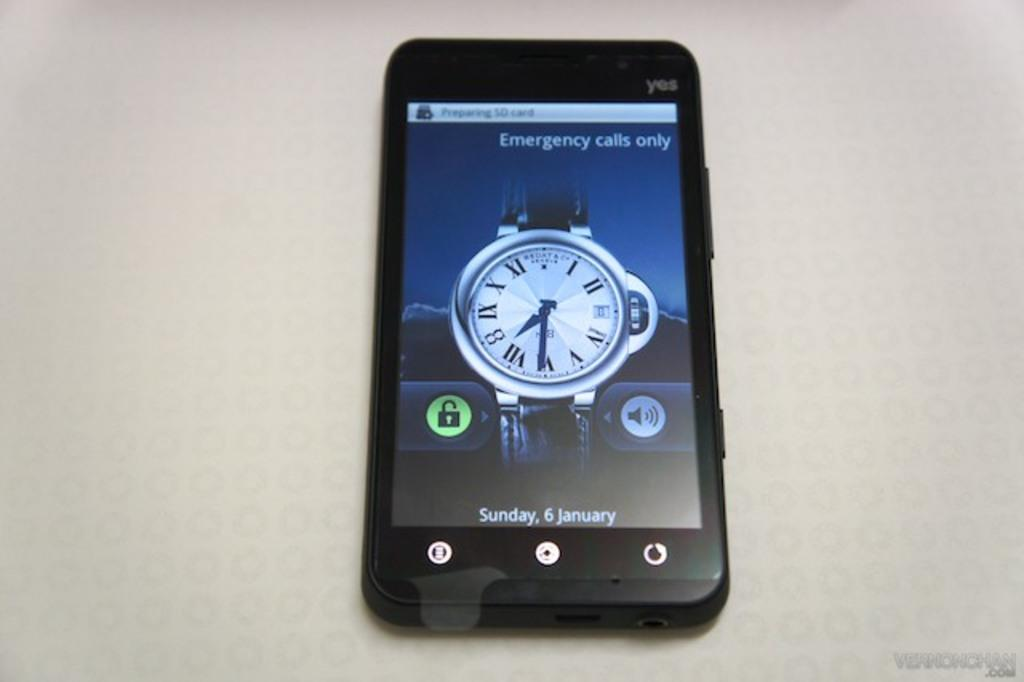<image>
Give a short and clear explanation of the subsequent image. The screen on the phone is set for emergency calls only. 